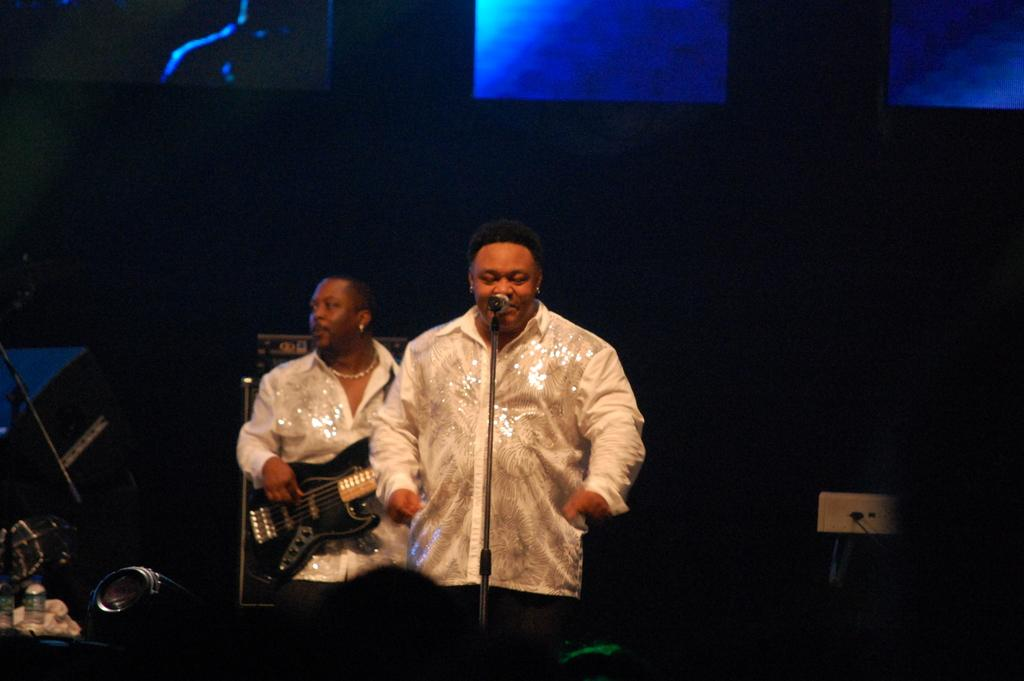How many people are in the image? There are two persons in the image. What are the two people doing in the image? One person is singing a song, and the other person is playing a guitar. What type of science experiment is being conducted in the image? There is no science experiment present in the image; it features two people engaged in musical activities. What type of plough is visible in the image? There is no plough present in the image. 